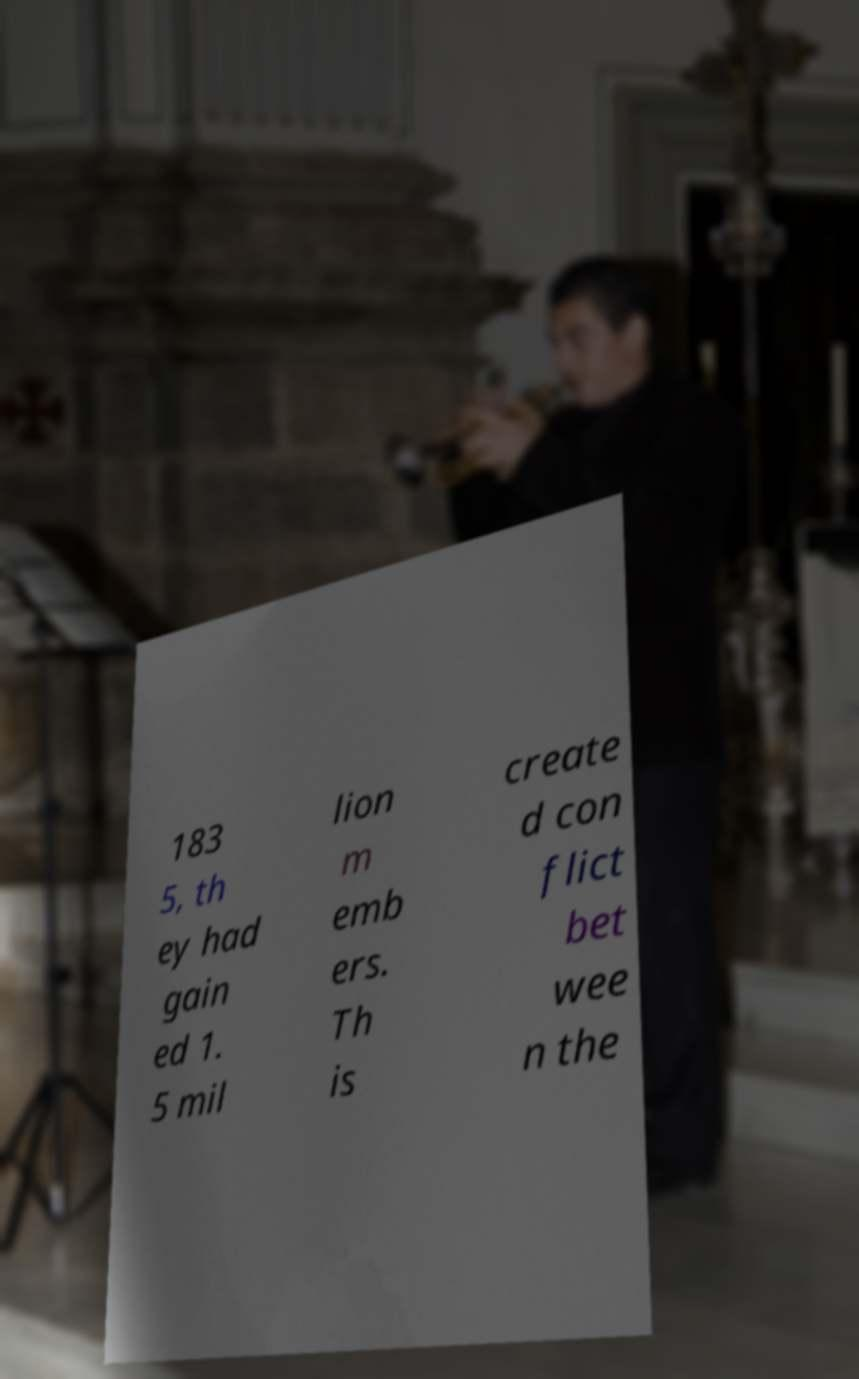Can you accurately transcribe the text from the provided image for me? 183 5, th ey had gain ed 1. 5 mil lion m emb ers. Th is create d con flict bet wee n the 